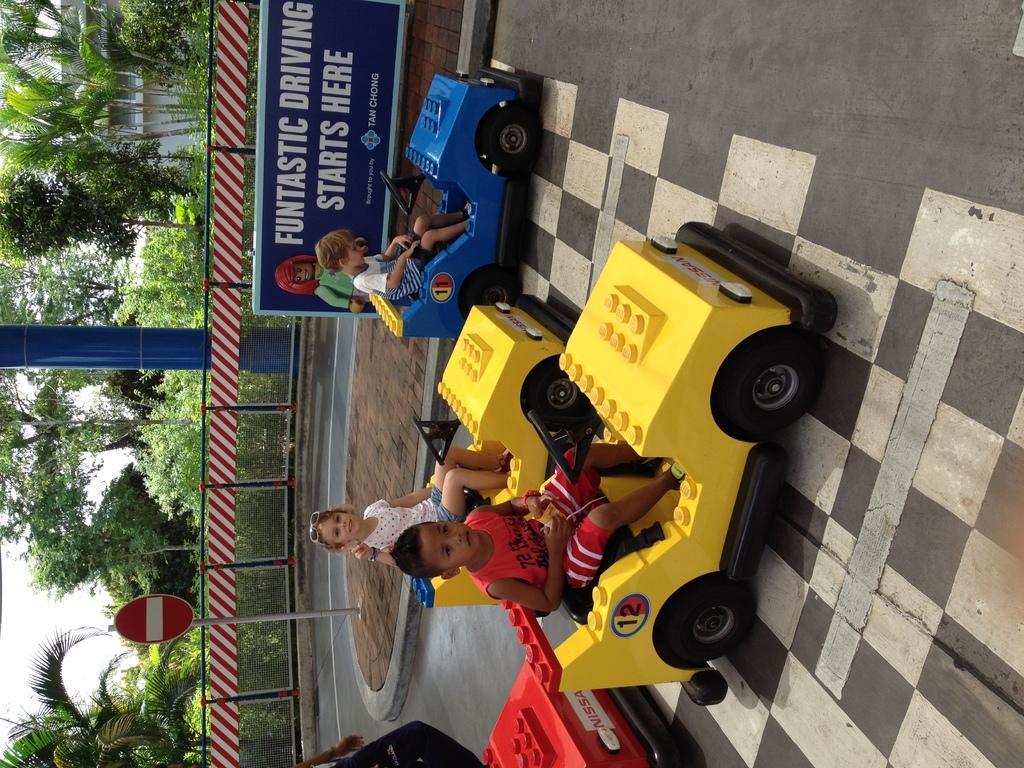Could you give a brief overview of what you see in this image? In this image we can see some children sitting inside the toy cars which are placed on the surface. On the backside we can see a board with some text, a fence, a signboard, a pole, a building, a group of trees and the sky. 